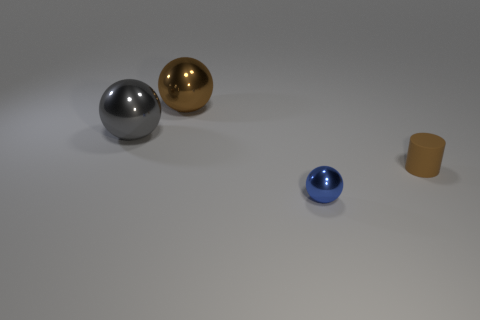Add 4 green cubes. How many objects exist? 8 Subtract all spheres. How many objects are left? 1 Subtract 0 red cylinders. How many objects are left? 4 Subtract all tiny blue shiny spheres. Subtract all small brown objects. How many objects are left? 2 Add 1 metal spheres. How many metal spheres are left? 4 Add 4 balls. How many balls exist? 7 